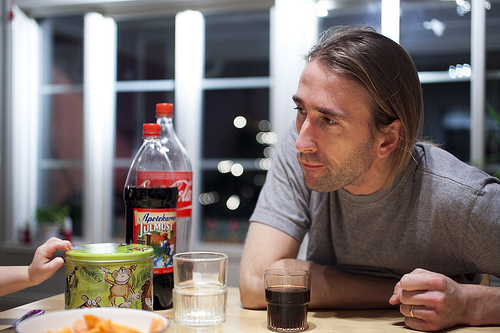<image>
Is there a drink on the person? No. The drink is not positioned on the person. They may be near each other, but the drink is not supported by or resting on top of the person. Where is the window in relation to the bottle? Is it next to the bottle? Yes. The window is positioned adjacent to the bottle, located nearby in the same general area. 